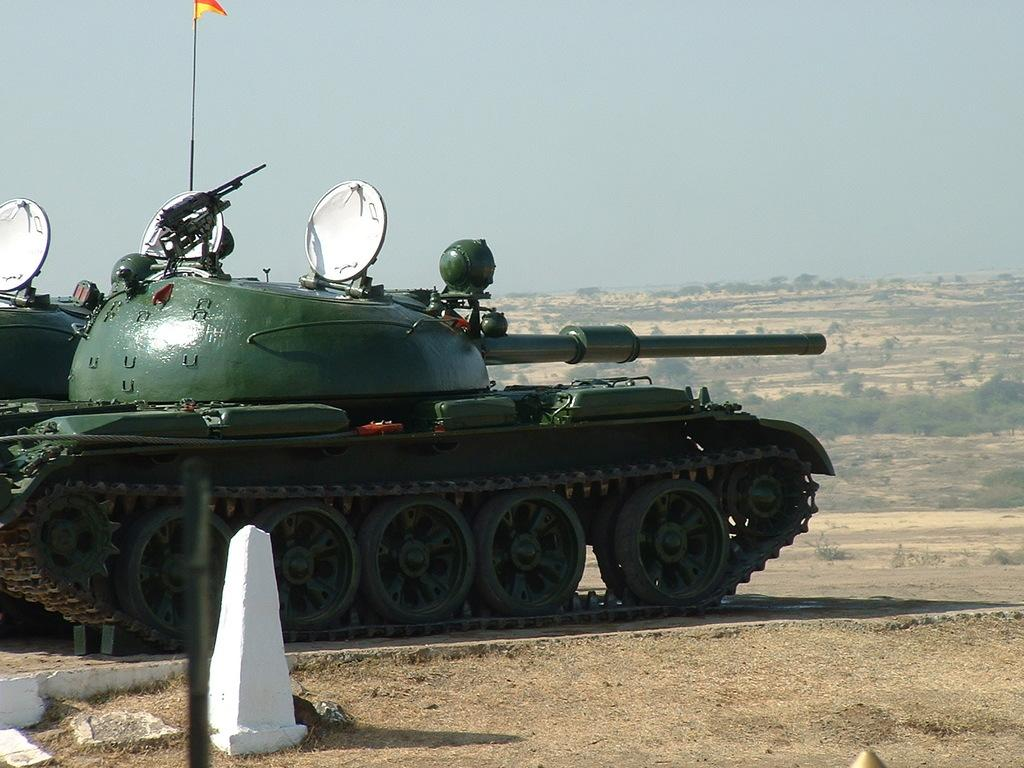What type of vehicle is on the path in the image? There is a war tank on the path in the image. What can be seen on the ground in the image? The ground is visible in the image, along with plants, soil, grass, and a flag. What is the natural environment like in the image? The natural environment includes plants, soil, and grass. What is visible in the sky in the image? The sky is visible in the image. What type of disgust can be seen on the minister's face in the image? There is no minister or any indication of disgust present in the image. 